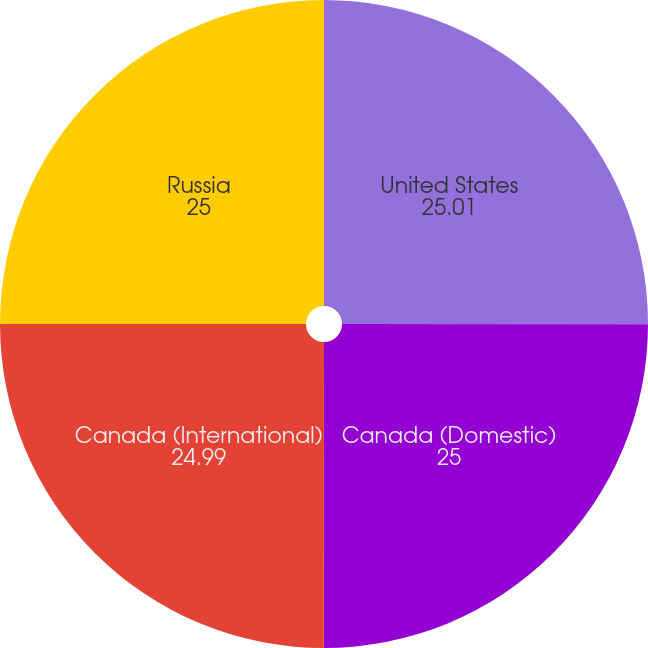Convert chart. <chart><loc_0><loc_0><loc_500><loc_500><pie_chart><fcel>United States<fcel>Canada (Domestic)<fcel>Canada (International)<fcel>Russia<nl><fcel>25.01%<fcel>25.0%<fcel>24.99%<fcel>25.0%<nl></chart> 